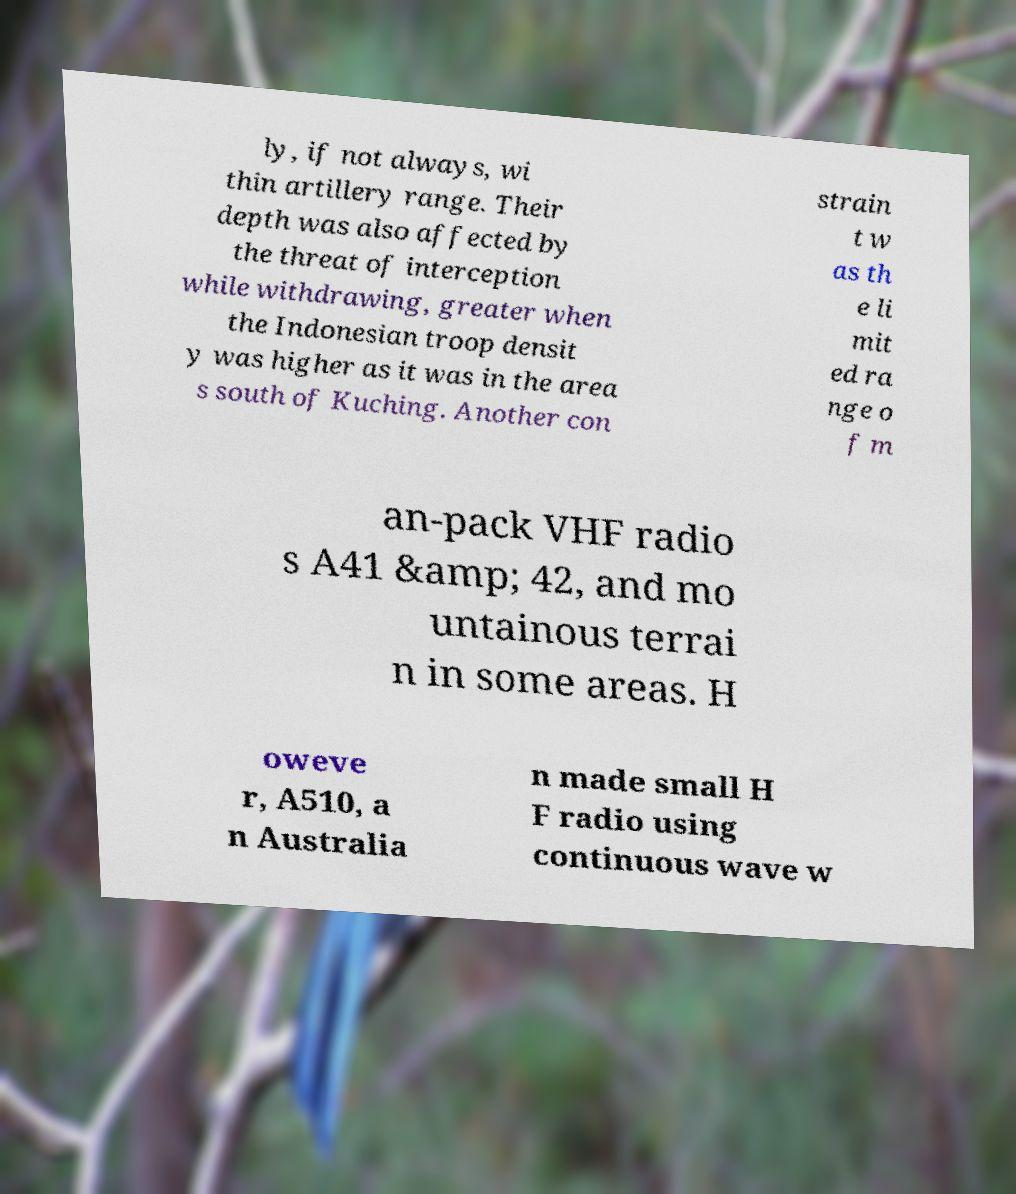Can you read and provide the text displayed in the image?This photo seems to have some interesting text. Can you extract and type it out for me? ly, if not always, wi thin artillery range. Their depth was also affected by the threat of interception while withdrawing, greater when the Indonesian troop densit y was higher as it was in the area s south of Kuching. Another con strain t w as th e li mit ed ra nge o f m an-pack VHF radio s A41 &amp; 42, and mo untainous terrai n in some areas. H oweve r, A510, a n Australia n made small H F radio using continuous wave w 